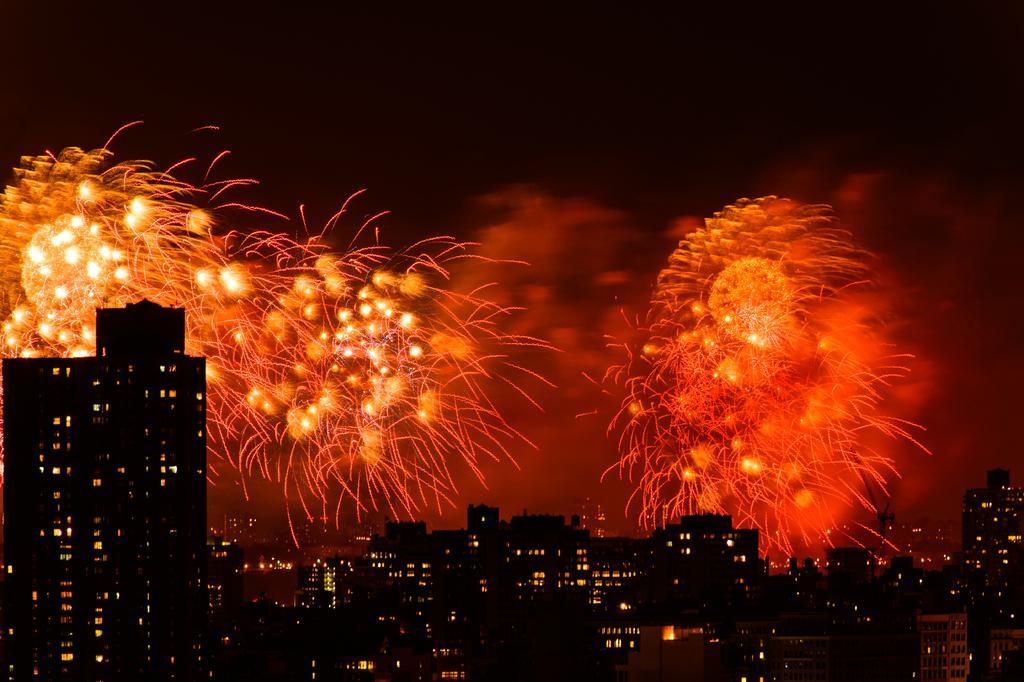Can you describe this image briefly? In this image, we can see some buildings. There are crackers in the sky. 